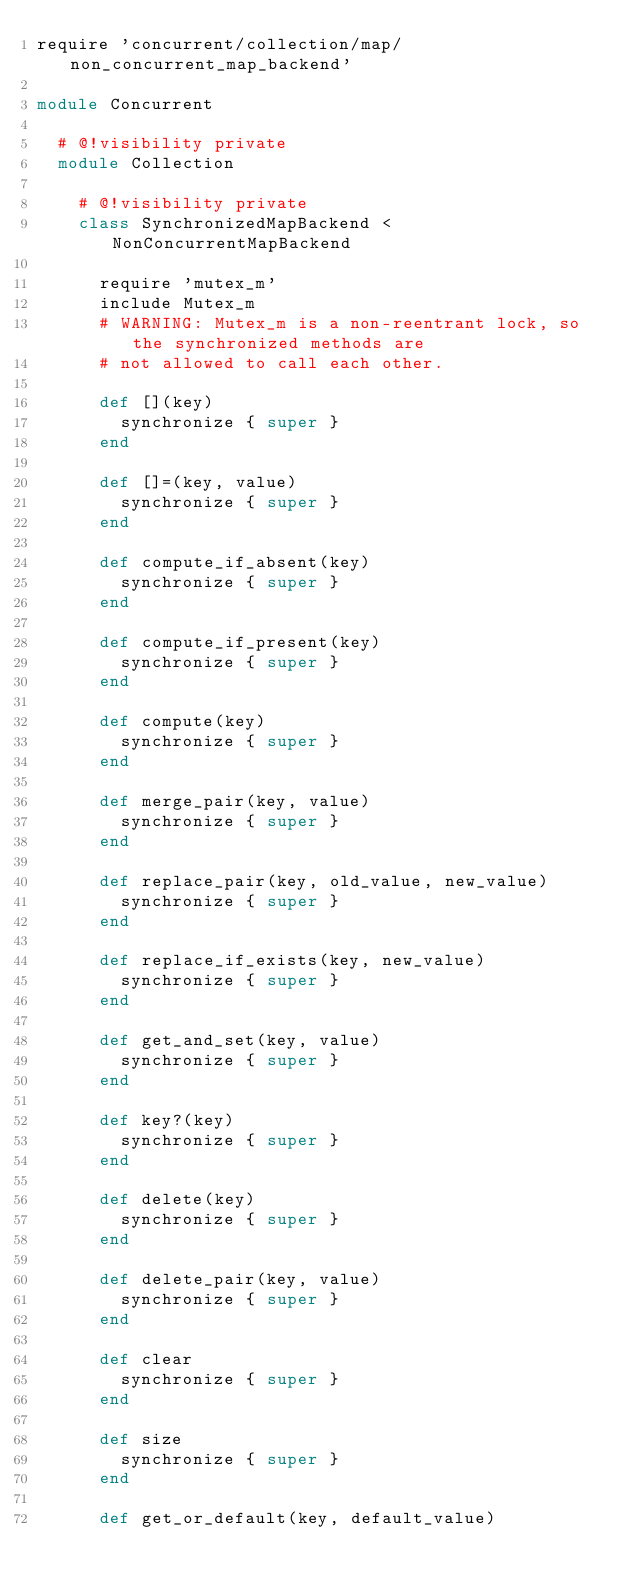Convert code to text. <code><loc_0><loc_0><loc_500><loc_500><_Ruby_>require 'concurrent/collection/map/non_concurrent_map_backend'

module Concurrent

  # @!visibility private
  module Collection

    # @!visibility private
    class SynchronizedMapBackend < NonConcurrentMapBackend

      require 'mutex_m'
      include Mutex_m
      # WARNING: Mutex_m is a non-reentrant lock, so the synchronized methods are
      # not allowed to call each other.

      def [](key)
        synchronize { super }
      end

      def []=(key, value)
        synchronize { super }
      end

      def compute_if_absent(key)
        synchronize { super }
      end

      def compute_if_present(key)
        synchronize { super }
      end

      def compute(key)
        synchronize { super }
      end

      def merge_pair(key, value)
        synchronize { super }
      end

      def replace_pair(key, old_value, new_value)
        synchronize { super }
      end

      def replace_if_exists(key, new_value)
        synchronize { super }
      end

      def get_and_set(key, value)
        synchronize { super }
      end

      def key?(key)
        synchronize { super }
      end

      def delete(key)
        synchronize { super }
      end

      def delete_pair(key, value)
        synchronize { super }
      end

      def clear
        synchronize { super }
      end

      def size
        synchronize { super }
      end

      def get_or_default(key, default_value)</code> 